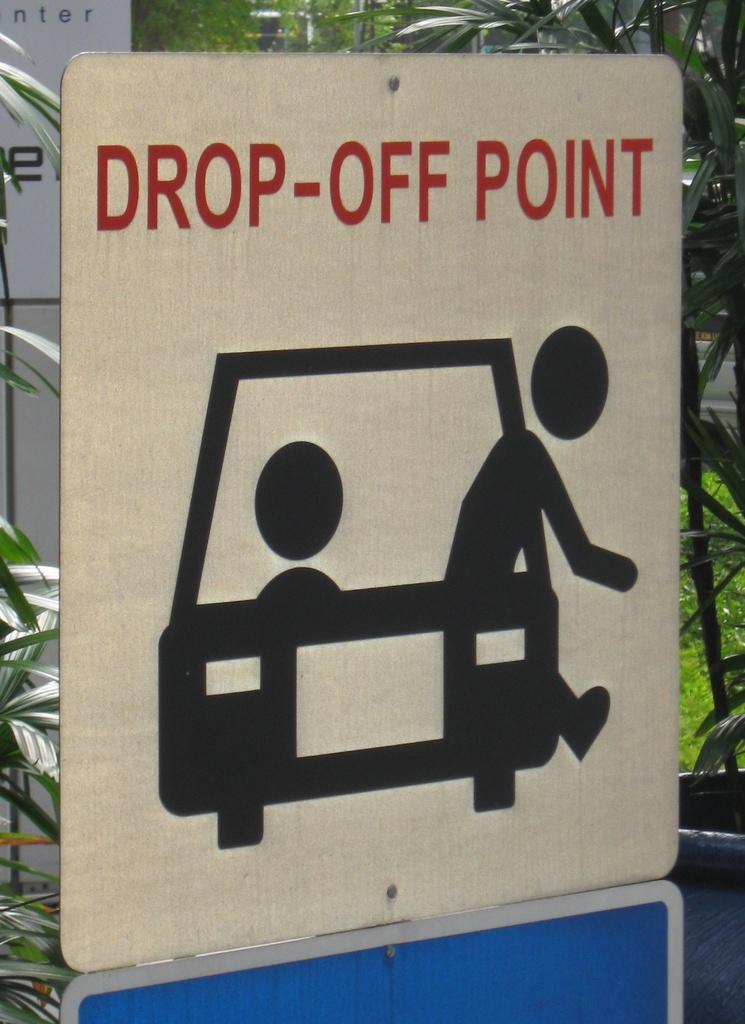<image>
Write a terse but informative summary of the picture. A sign indicates where to drop people off. 